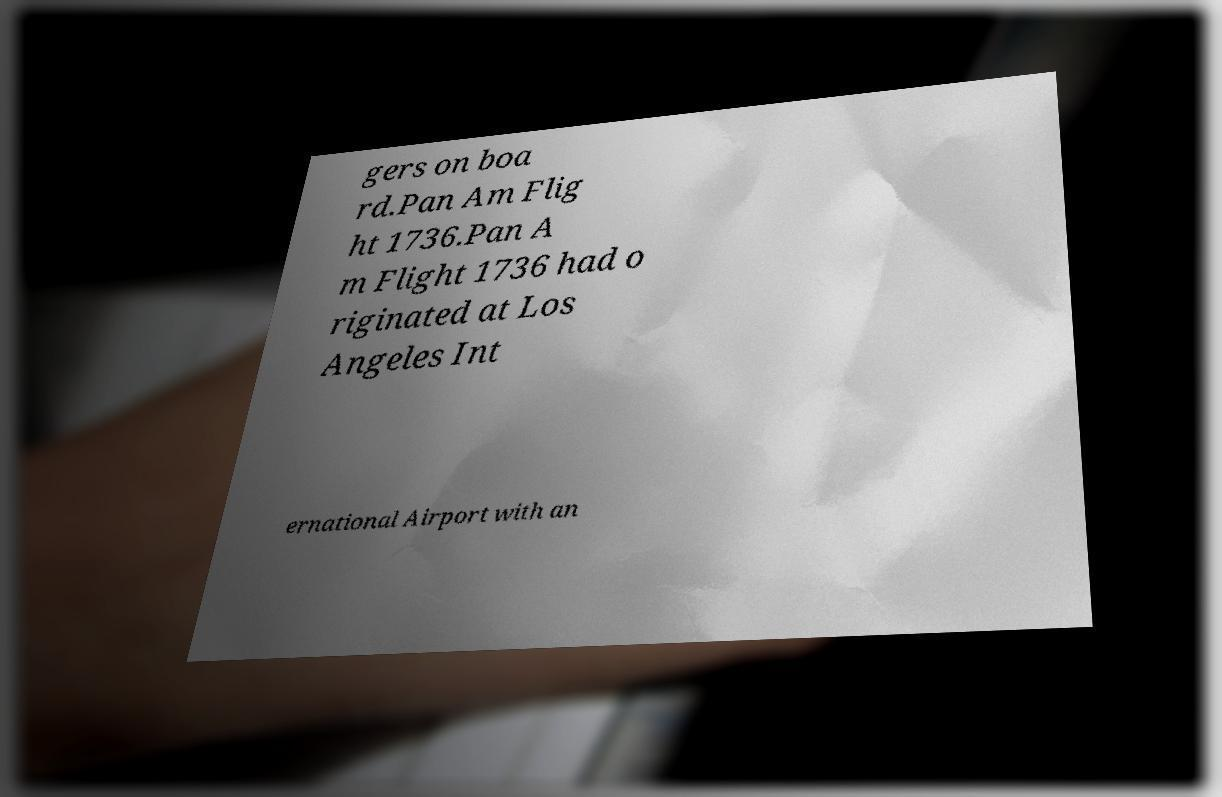Could you extract and type out the text from this image? gers on boa rd.Pan Am Flig ht 1736.Pan A m Flight 1736 had o riginated at Los Angeles Int ernational Airport with an 